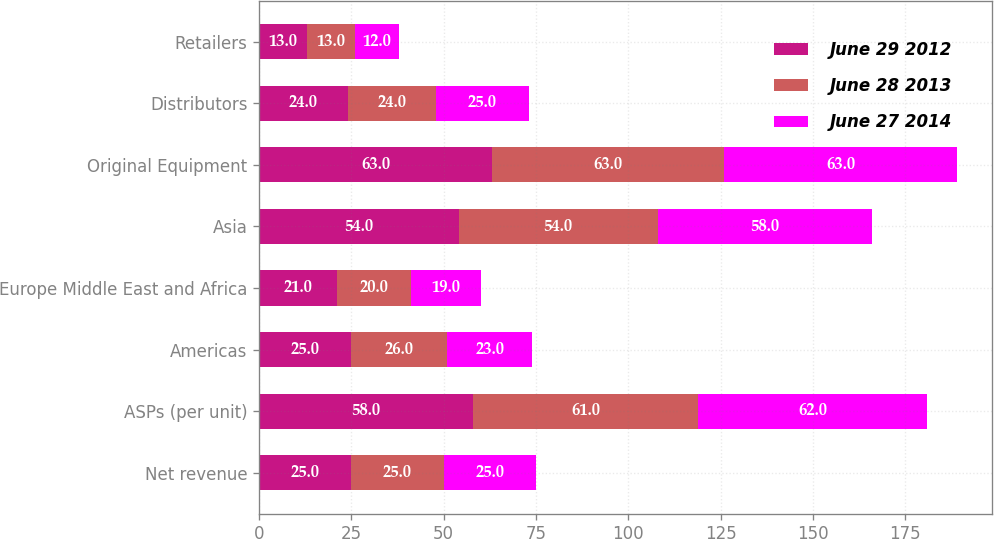<chart> <loc_0><loc_0><loc_500><loc_500><stacked_bar_chart><ecel><fcel>Net revenue<fcel>ASPs (per unit)<fcel>Americas<fcel>Europe Middle East and Africa<fcel>Asia<fcel>Original Equipment<fcel>Distributors<fcel>Retailers<nl><fcel>June 29 2012<fcel>25<fcel>58<fcel>25<fcel>21<fcel>54<fcel>63<fcel>24<fcel>13<nl><fcel>June 28 2013<fcel>25<fcel>61<fcel>26<fcel>20<fcel>54<fcel>63<fcel>24<fcel>13<nl><fcel>June 27 2014<fcel>25<fcel>62<fcel>23<fcel>19<fcel>58<fcel>63<fcel>25<fcel>12<nl></chart> 